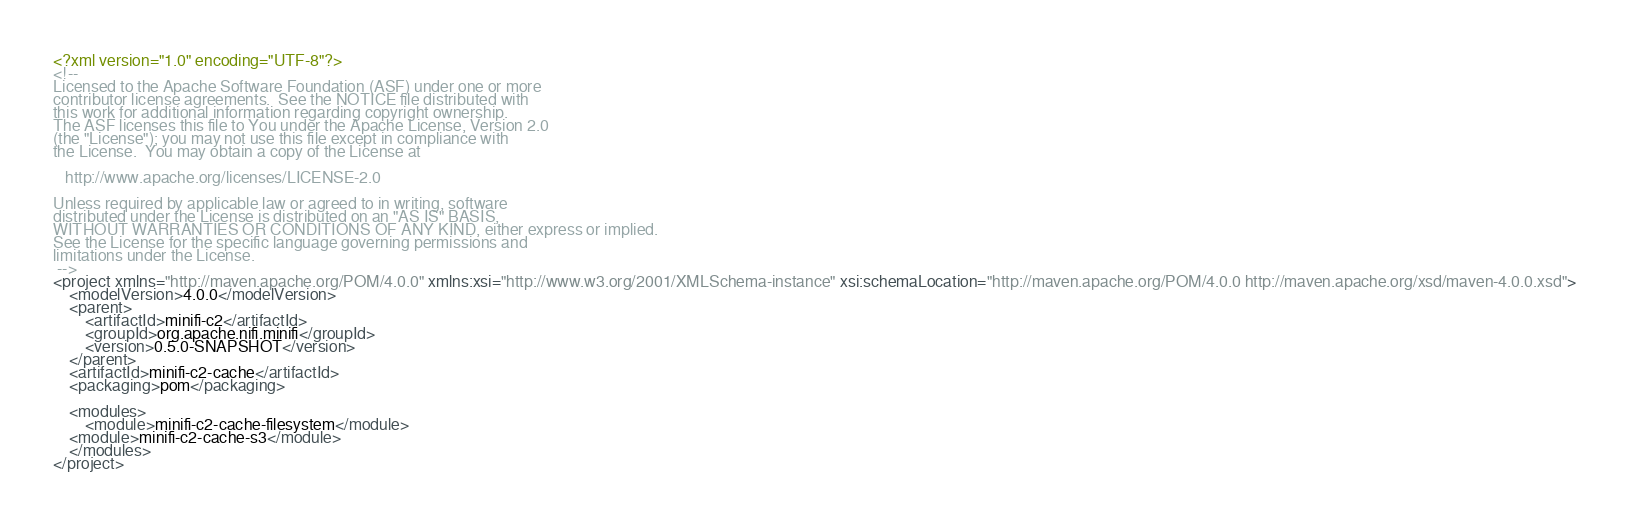Convert code to text. <code><loc_0><loc_0><loc_500><loc_500><_XML_><?xml version="1.0" encoding="UTF-8"?>
<!--
Licensed to the Apache Software Foundation (ASF) under one or more
contributor license agreements.  See the NOTICE file distributed with
this work for additional information regarding copyright ownership.
The ASF licenses this file to You under the Apache License, Version 2.0
(the "License"); you may not use this file except in compliance with
the License.  You may obtain a copy of the License at

   http://www.apache.org/licenses/LICENSE-2.0

Unless required by applicable law or agreed to in writing, software
distributed under the License is distributed on an "AS IS" BASIS,
WITHOUT WARRANTIES OR CONDITIONS OF ANY KIND, either express or implied.
See the License for the specific language governing permissions and
limitations under the License.
 -->
<project xmlns="http://maven.apache.org/POM/4.0.0" xmlns:xsi="http://www.w3.org/2001/XMLSchema-instance" xsi:schemaLocation="http://maven.apache.org/POM/4.0.0 http://maven.apache.org/xsd/maven-4.0.0.xsd">
    <modelVersion>4.0.0</modelVersion>
    <parent>
        <artifactId>minifi-c2</artifactId>
        <groupId>org.apache.nifi.minifi</groupId>
        <version>0.5.0-SNAPSHOT</version>
    </parent>
    <artifactId>minifi-c2-cache</artifactId>
    <packaging>pom</packaging>

    <modules>
        <module>minifi-c2-cache-filesystem</module>
	<module>minifi-c2-cache-s3</module>
    </modules>
</project>
</code> 